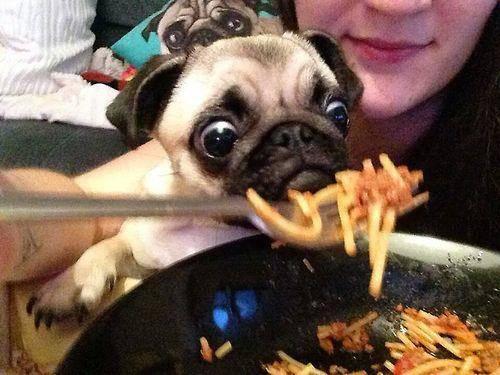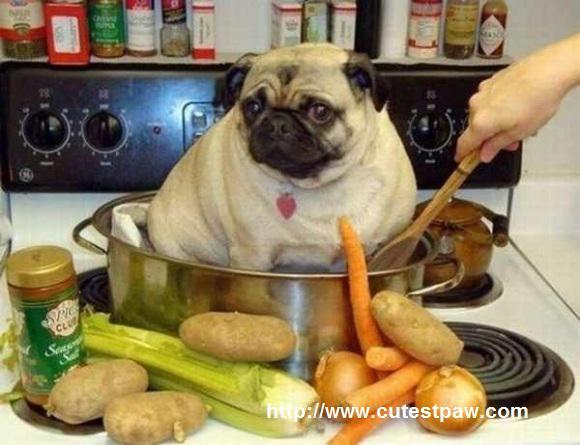The first image is the image on the left, the second image is the image on the right. Analyze the images presented: Is the assertion "The dog in the image on the left is sitting before a white plate of food." valid? Answer yes or no. No. 